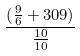Convert formula to latex. <formula><loc_0><loc_0><loc_500><loc_500>\frac { ( \frac { 9 } { 6 } + 3 0 9 ) } { \frac { 1 0 } { 1 0 } }</formula> 